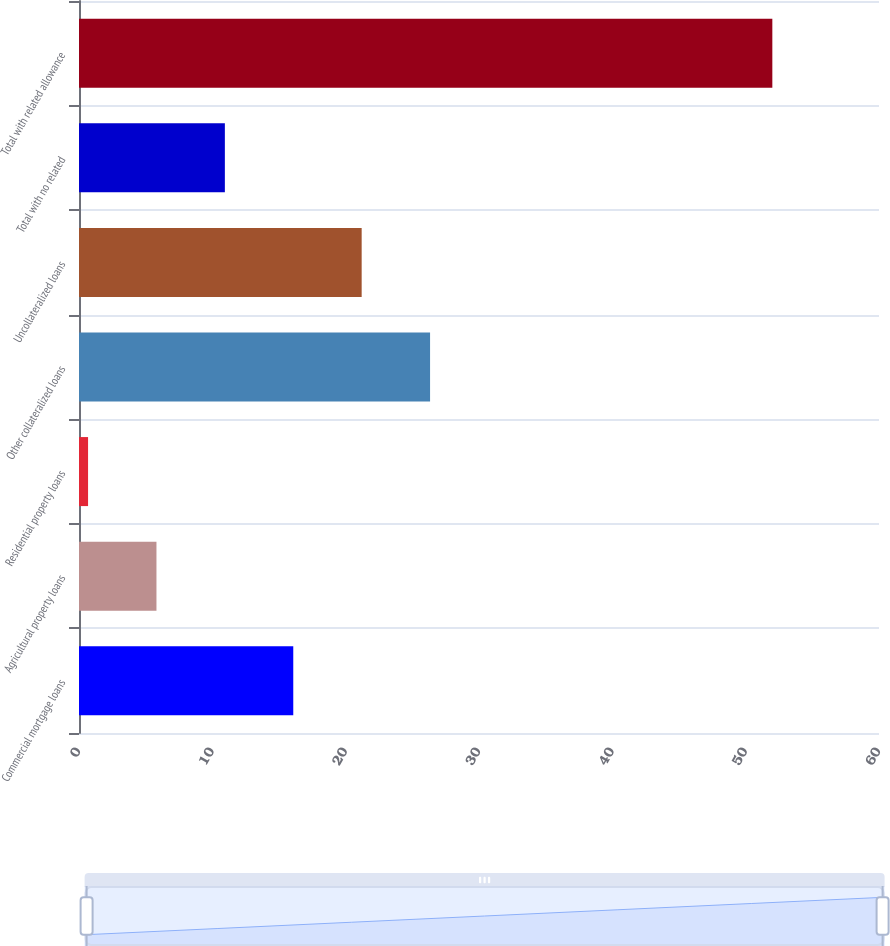<chart> <loc_0><loc_0><loc_500><loc_500><bar_chart><fcel>Commercial mortgage loans<fcel>Agricultural property loans<fcel>Residential property loans<fcel>Other collateralized loans<fcel>Uncollateralized loans<fcel>Total with no related<fcel>Total with related allowance<nl><fcel>16.07<fcel>5.81<fcel>0.68<fcel>26.33<fcel>21.2<fcel>10.94<fcel>52<nl></chart> 